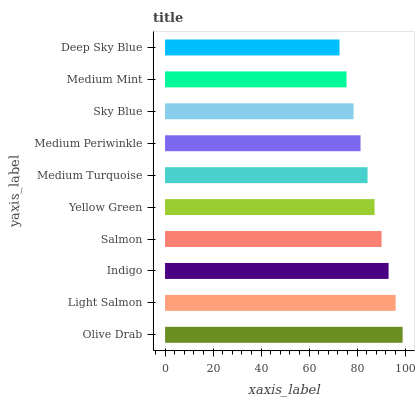Is Deep Sky Blue the minimum?
Answer yes or no. Yes. Is Olive Drab the maximum?
Answer yes or no. Yes. Is Light Salmon the minimum?
Answer yes or no. No. Is Light Salmon the maximum?
Answer yes or no. No. Is Olive Drab greater than Light Salmon?
Answer yes or no. Yes. Is Light Salmon less than Olive Drab?
Answer yes or no. Yes. Is Light Salmon greater than Olive Drab?
Answer yes or no. No. Is Olive Drab less than Light Salmon?
Answer yes or no. No. Is Yellow Green the high median?
Answer yes or no. Yes. Is Medium Turquoise the low median?
Answer yes or no. Yes. Is Sky Blue the high median?
Answer yes or no. No. Is Light Salmon the low median?
Answer yes or no. No. 